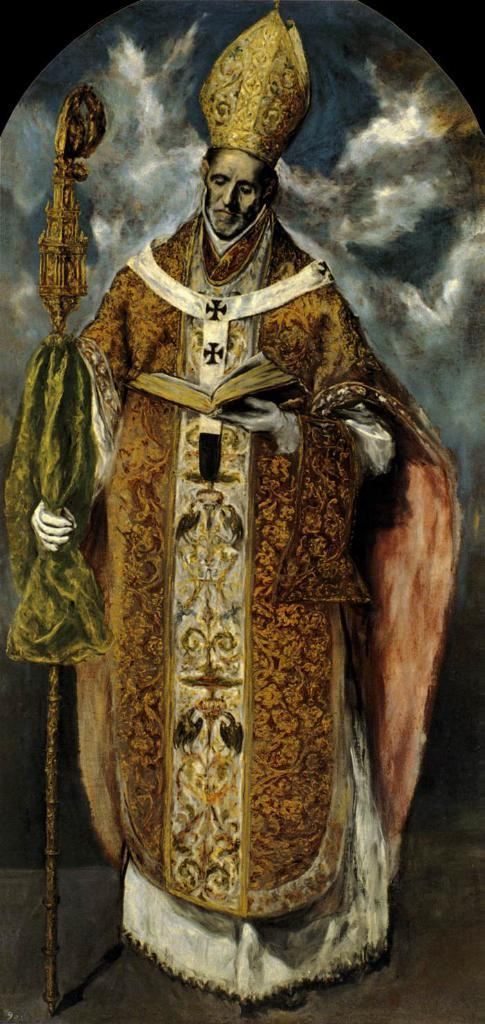What is the main subject of the image? There is a person in the image. What is the person doing in the image? The person is standing. What objects is the person holding in the image? The person is holding a stick with one hand and a book with the other hand. What accessory is the person wearing in the image? The person is wearing a crown. What time of day is it in the image? The provided facts do not mention the time of day, so it cannot be determined from the image. 